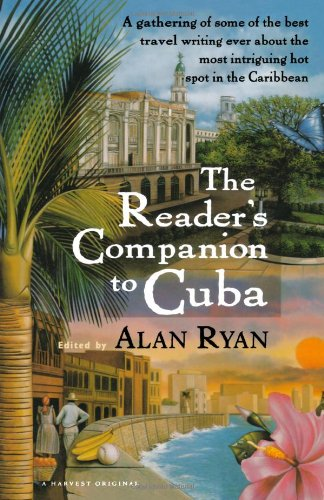Is this book related to Travel? Yes, the book is indeed related to travel, featuring a compilation of travel writing about Cuba. 